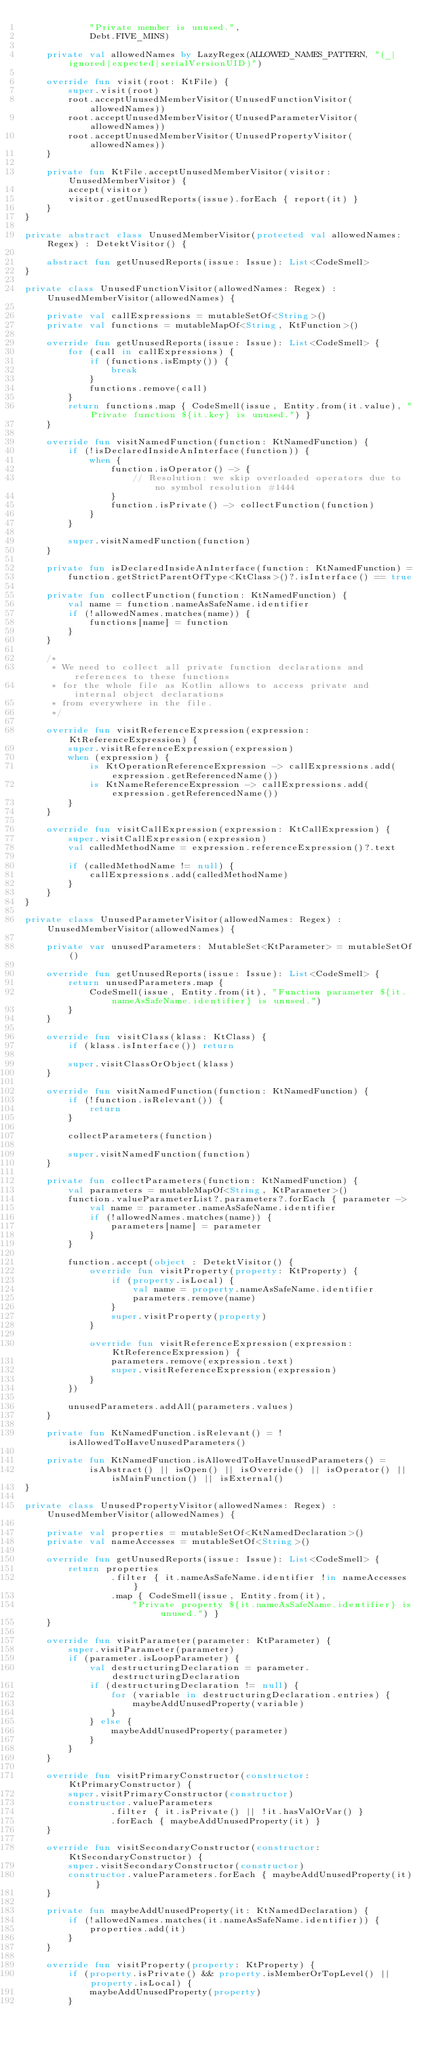<code> <loc_0><loc_0><loc_500><loc_500><_Kotlin_>            "Private member is unused.",
            Debt.FIVE_MINS)

    private val allowedNames by LazyRegex(ALLOWED_NAMES_PATTERN, "(_|ignored|expected|serialVersionUID)")

    override fun visit(root: KtFile) {
        super.visit(root)
        root.acceptUnusedMemberVisitor(UnusedFunctionVisitor(allowedNames))
        root.acceptUnusedMemberVisitor(UnusedParameterVisitor(allowedNames))
        root.acceptUnusedMemberVisitor(UnusedPropertyVisitor(allowedNames))
    }

    private fun KtFile.acceptUnusedMemberVisitor(visitor: UnusedMemberVisitor) {
        accept(visitor)
        visitor.getUnusedReports(issue).forEach { report(it) }
    }
}

private abstract class UnusedMemberVisitor(protected val allowedNames: Regex) : DetektVisitor() {

    abstract fun getUnusedReports(issue: Issue): List<CodeSmell>
}

private class UnusedFunctionVisitor(allowedNames: Regex) : UnusedMemberVisitor(allowedNames) {

    private val callExpressions = mutableSetOf<String>()
    private val functions = mutableMapOf<String, KtFunction>()

    override fun getUnusedReports(issue: Issue): List<CodeSmell> {
        for (call in callExpressions) {
            if (functions.isEmpty()) {
                break
            }
            functions.remove(call)
        }
        return functions.map { CodeSmell(issue, Entity.from(it.value), "Private function ${it.key} is unused.") }
    }

    override fun visitNamedFunction(function: KtNamedFunction) {
        if (!isDeclaredInsideAnInterface(function)) {
            when {
                function.isOperator() -> {
                    // Resolution: we skip overloaded operators due to no symbol resolution #1444
                }
                function.isPrivate() -> collectFunction(function)
            }
        }

        super.visitNamedFunction(function)
    }

    private fun isDeclaredInsideAnInterface(function: KtNamedFunction) =
        function.getStrictParentOfType<KtClass>()?.isInterface() == true

    private fun collectFunction(function: KtNamedFunction) {
        val name = function.nameAsSafeName.identifier
        if (!allowedNames.matches(name)) {
            functions[name] = function
        }
    }

    /*
     * We need to collect all private function declarations and references to these functions
     * for the whole file as Kotlin allows to access private and internal object declarations
     * from everywhere in the file.
     */

    override fun visitReferenceExpression(expression: KtReferenceExpression) {
        super.visitReferenceExpression(expression)
        when (expression) {
            is KtOperationReferenceExpression -> callExpressions.add(expression.getReferencedName())
            is KtNameReferenceExpression -> callExpressions.add(expression.getReferencedName())
        }
    }

    override fun visitCallExpression(expression: KtCallExpression) {
        super.visitCallExpression(expression)
        val calledMethodName = expression.referenceExpression()?.text

        if (calledMethodName != null) {
            callExpressions.add(calledMethodName)
        }
    }
}

private class UnusedParameterVisitor(allowedNames: Regex) : UnusedMemberVisitor(allowedNames) {

    private var unusedParameters: MutableSet<KtParameter> = mutableSetOf()

    override fun getUnusedReports(issue: Issue): List<CodeSmell> {
        return unusedParameters.map {
            CodeSmell(issue, Entity.from(it), "Function parameter ${it.nameAsSafeName.identifier} is unused.")
        }
    }

    override fun visitClass(klass: KtClass) {
        if (klass.isInterface()) return

        super.visitClassOrObject(klass)
    }

    override fun visitNamedFunction(function: KtNamedFunction) {
        if (!function.isRelevant()) {
            return
        }

        collectParameters(function)

        super.visitNamedFunction(function)
    }

    private fun collectParameters(function: KtNamedFunction) {
        val parameters = mutableMapOf<String, KtParameter>()
        function.valueParameterList?.parameters?.forEach { parameter ->
            val name = parameter.nameAsSafeName.identifier
            if (!allowedNames.matches(name)) {
                parameters[name] = parameter
            }
        }

        function.accept(object : DetektVisitor() {
            override fun visitProperty(property: KtProperty) {
                if (property.isLocal) {
                    val name = property.nameAsSafeName.identifier
                    parameters.remove(name)
                }
                super.visitProperty(property)
            }

            override fun visitReferenceExpression(expression: KtReferenceExpression) {
                parameters.remove(expression.text)
                super.visitReferenceExpression(expression)
            }
        })

        unusedParameters.addAll(parameters.values)
    }

    private fun KtNamedFunction.isRelevant() = !isAllowedToHaveUnusedParameters()

    private fun KtNamedFunction.isAllowedToHaveUnusedParameters() =
            isAbstract() || isOpen() || isOverride() || isOperator() || isMainFunction() || isExternal()
}

private class UnusedPropertyVisitor(allowedNames: Regex) : UnusedMemberVisitor(allowedNames) {

    private val properties = mutableSetOf<KtNamedDeclaration>()
    private val nameAccesses = mutableSetOf<String>()

    override fun getUnusedReports(issue: Issue): List<CodeSmell> {
        return properties
                .filter { it.nameAsSafeName.identifier !in nameAccesses }
                .map { CodeSmell(issue, Entity.from(it),
                    "Private property ${it.nameAsSafeName.identifier} is unused.") }
    }

    override fun visitParameter(parameter: KtParameter) {
        super.visitParameter(parameter)
        if (parameter.isLoopParameter) {
            val destructuringDeclaration = parameter.destructuringDeclaration
            if (destructuringDeclaration != null) {
                for (variable in destructuringDeclaration.entries) {
                    maybeAddUnusedProperty(variable)
                }
            } else {
                maybeAddUnusedProperty(parameter)
            }
        }
    }

    override fun visitPrimaryConstructor(constructor: KtPrimaryConstructor) {
        super.visitPrimaryConstructor(constructor)
        constructor.valueParameters
                .filter { it.isPrivate() || !it.hasValOrVar() }
                .forEach { maybeAddUnusedProperty(it) }
    }

    override fun visitSecondaryConstructor(constructor: KtSecondaryConstructor) {
        super.visitSecondaryConstructor(constructor)
        constructor.valueParameters.forEach { maybeAddUnusedProperty(it) }
    }

    private fun maybeAddUnusedProperty(it: KtNamedDeclaration) {
        if (!allowedNames.matches(it.nameAsSafeName.identifier)) {
            properties.add(it)
        }
    }

    override fun visitProperty(property: KtProperty) {
        if (property.isPrivate() && property.isMemberOrTopLevel() || property.isLocal) {
            maybeAddUnusedProperty(property)
        }</code> 